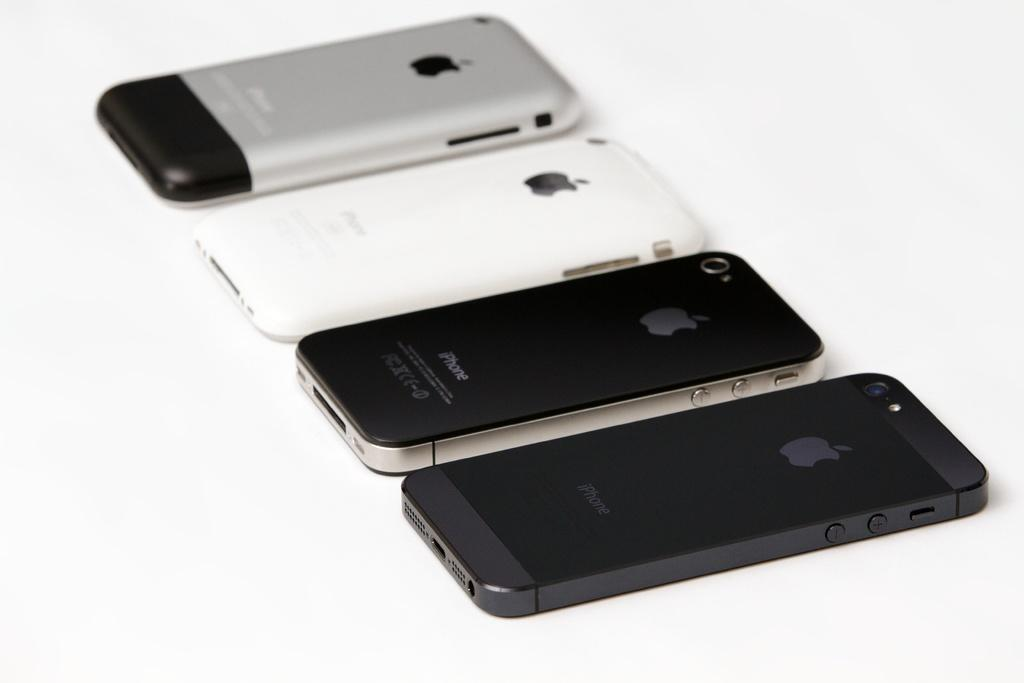Provide a one-sentence caption for the provided image. Four different generation iPhones are all laid out next to each other. 